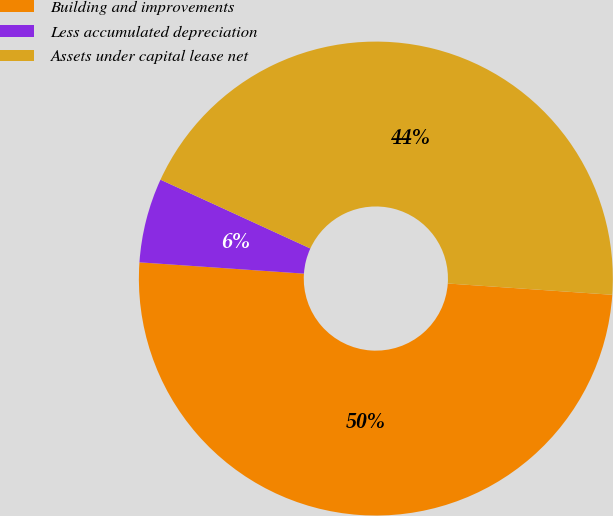Convert chart to OTSL. <chart><loc_0><loc_0><loc_500><loc_500><pie_chart><fcel>Building and improvements<fcel>Less accumulated depreciation<fcel>Assets under capital lease net<nl><fcel>50.0%<fcel>5.76%<fcel>44.24%<nl></chart> 